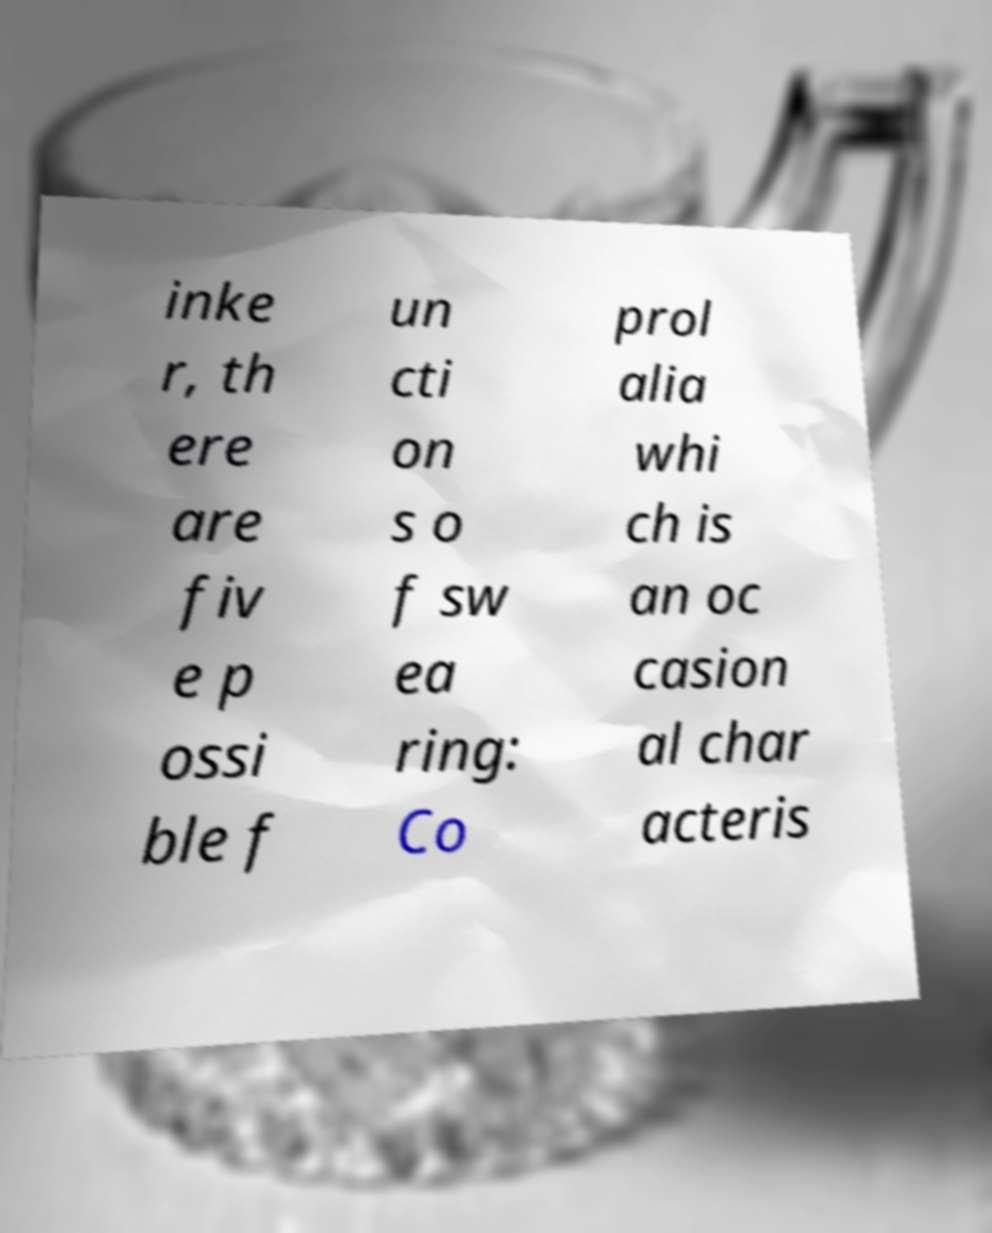There's text embedded in this image that I need extracted. Can you transcribe it verbatim? inke r, th ere are fiv e p ossi ble f un cti on s o f sw ea ring: Co prol alia whi ch is an oc casion al char acteris 